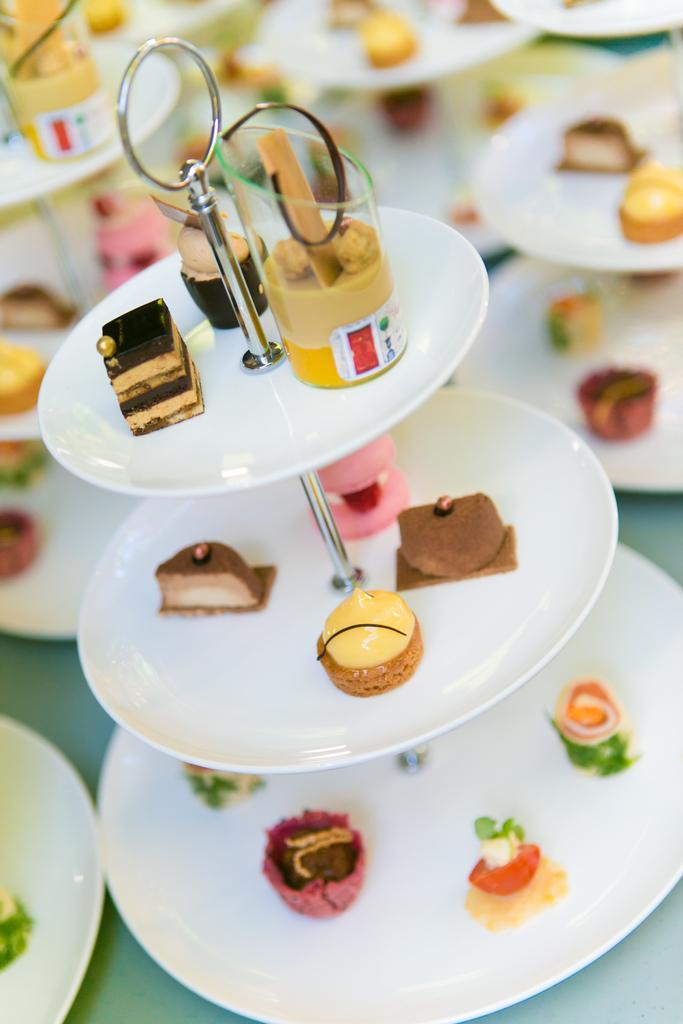What is placed on the plate stand in the image? There is food placed in a plate stand in the image. Can you describe the background of the image? There are plate stands and food visible in the background of the image. What type of anger can be seen on the faces of the snakes in the image? There are no snakes or expressions of anger present in the image. 